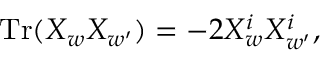Convert formula to latex. <formula><loc_0><loc_0><loc_500><loc_500>T r ( X _ { w } X _ { w ^ { \prime } } ) = - 2 X _ { w } ^ { i } X _ { w ^ { \prime } } ^ { i } ,</formula> 